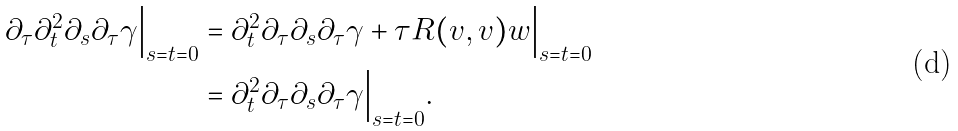Convert formula to latex. <formula><loc_0><loc_0><loc_500><loc_500>\partial _ { \tau } \partial _ { t } ^ { 2 } \partial _ { s } \partial _ { \tau } \gamma \Big | _ { s = t = 0 } & = \partial _ { t } ^ { 2 } \partial _ { \tau } \partial _ { s } \partial _ { \tau } \gamma + \tau R ( v , v ) w \Big | _ { s = t = 0 } \\ & = \partial _ { t } ^ { 2 } \partial _ { \tau } \partial _ { s } \partial _ { \tau } \gamma \Big | _ { s = t = 0 } .</formula> 